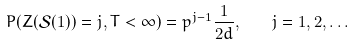<formula> <loc_0><loc_0><loc_500><loc_500>P ( Z ( \mathcal { S } ( 1 ) ) = j , T < \infty ) = p ^ { j - 1 } \frac { 1 } { 2 d } , \quad j = 1 , 2 , \dots</formula> 